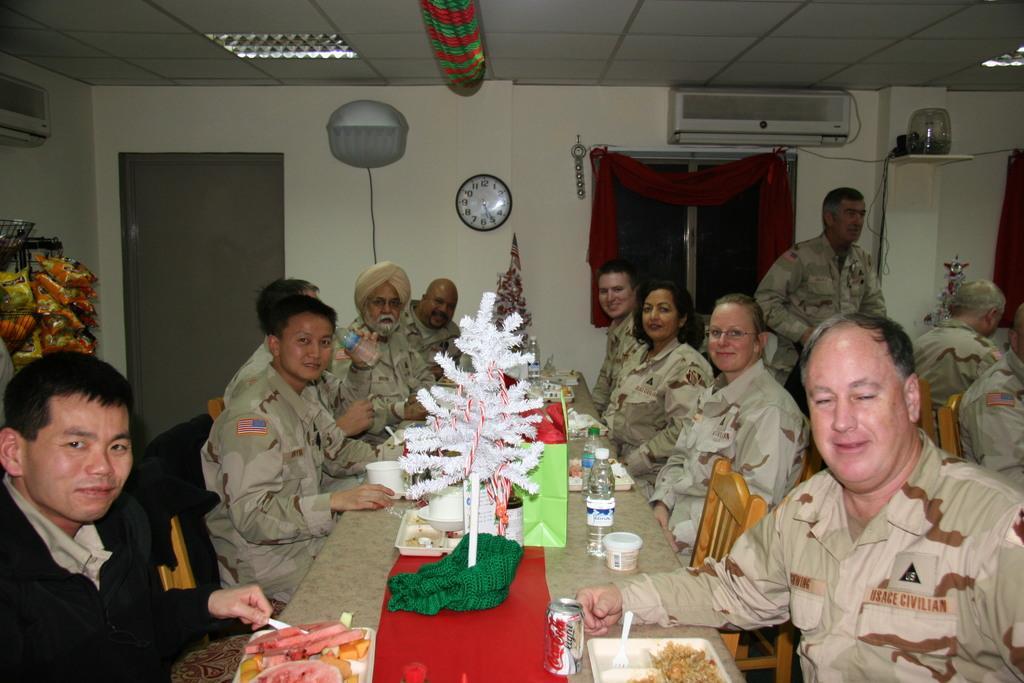Describe this image in one or two sentences. In this image there are a group of people who are sitting on chairs, and in the center there is one table. On the table there are flower bouquets, bottles, cups, plates and in the plates there are some food items. And on the right side also there are some persons, in the background there is a door, window, curtain, clock, air conditioner and some other objects. At the top there is ceiling and some lights. 